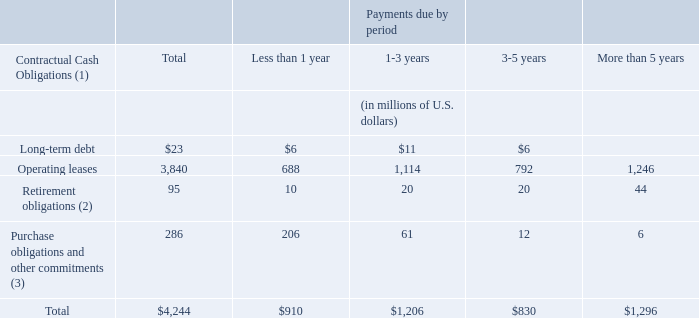Obligations and Commitments
As of August 31, 2019, we had the following obligations and commitments to make future payments under contracts, contractual obligations and commercial commitments:
Amounts in table may not total due to rounding.
The liability related to unrecognized tax benefits has been excluded from the contractual obligations table because a reasonable estimate of the timing and amount of cash outflows from future tax settlements cannot be determined. For additional information, see Note 10 (Income Taxes) to our Consolidated Financial Statements under Item 8, “Financial Statements and Supplementary Data.”
Amounts represent projected payments under certain unfunded retirement plans for former pre-incorporation partners. Given these plans are unfunded, we pay these benefits directly. These plans were eliminated for active partners after May 15, 2001
Other commitments include, among other things, information technology, software support and maintenance obligations, as well as other obligations in the ordinary course of business that we cannot cancel or where we would be required to pay a termination fee in the event of cancellation. Amounts shown do not include recourse that we may have to recover termination fees or penalties from clients.
What is the company's long-term debt due in 3-5 years?
Answer scale should be: million. $6. What does the company's retirement obligations refer to? Projected payments under certain unfunded retirement plans for former pre-incorporation partners. What is the company's total contractual cash obligations due in more than 5 years?
Answer scale should be: million. $1,296. What is the proportion of the company's total long term debt as a ratio of its total contractual cash obligations?
Answer scale should be: percent. (23/4,244)
Answer: 0.54. What is the total contractual cash obligation due in less than one year from long-term debt and operating leases?
Answer scale should be: million. $23 + $3,840 
Answer: 3863. How much does operating leases account for total contractual cash obligations for period of less than 1 year?
Answer scale should be: percent. $688/910 
Answer: 75.6. 